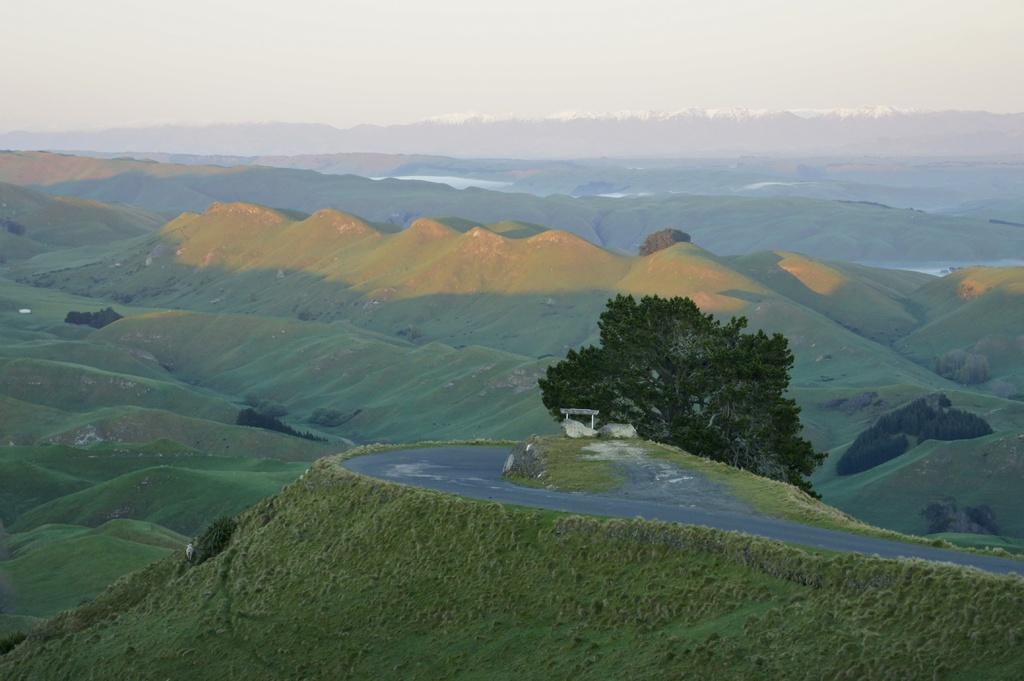Please provide a concise description of this image. In this image there are hills. There is grass and plants on the hills. To the right there is a road on the hill. Beside the road there is a tree. At the top there is the sky. 